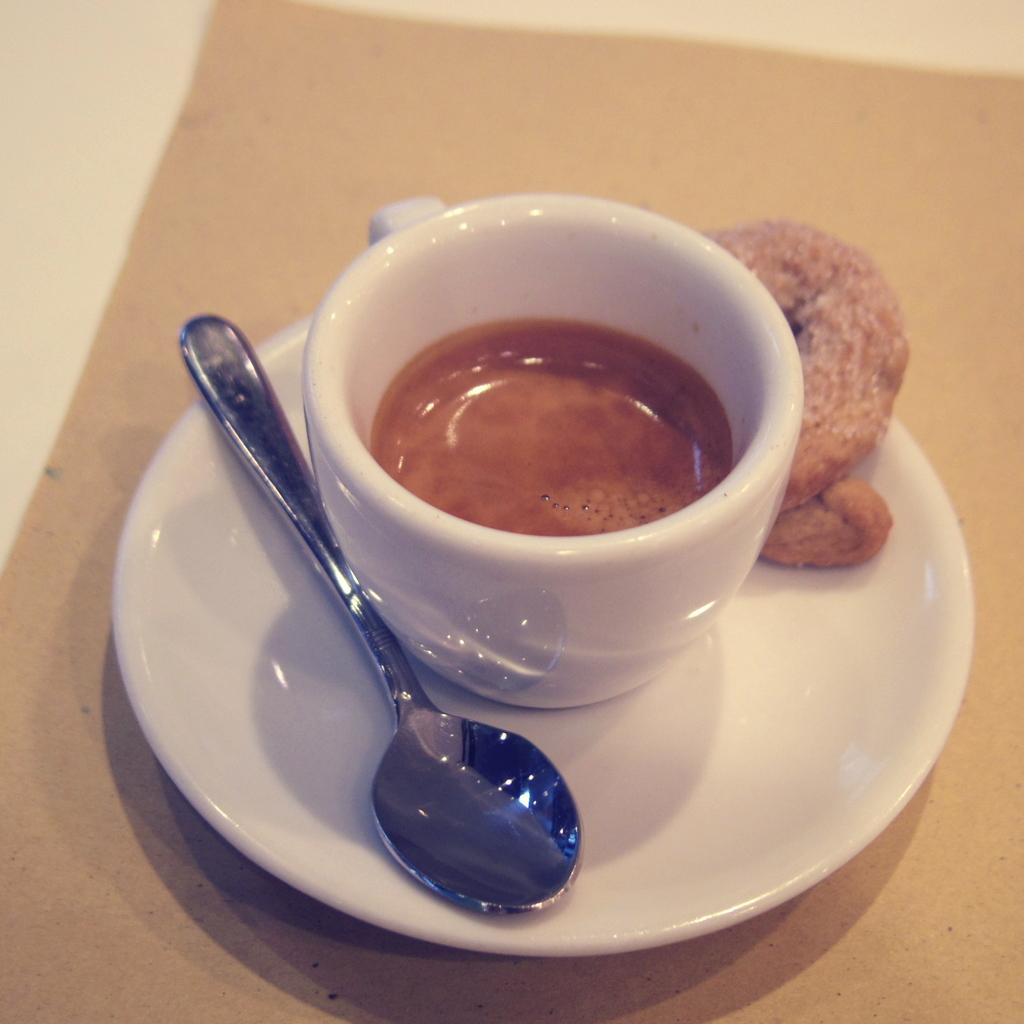What piece of furniture is visible in the image? There is a table in the image. What is placed on the table? A teacup is placed on the table, and a saucer is placed under the teacup. What is on the saucer? A spoon and a food item are on the saucer. How do the brothers feel about the shame they experienced in the image? There are no brothers or any indication of shame present in the image. 